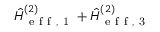<formula> <loc_0><loc_0><loc_500><loc_500>\hat { H } _ { e f f , 1 } ^ { ( 2 ) } + \hat { H } _ { e f f , 3 } ^ { ( 2 ) }</formula> 